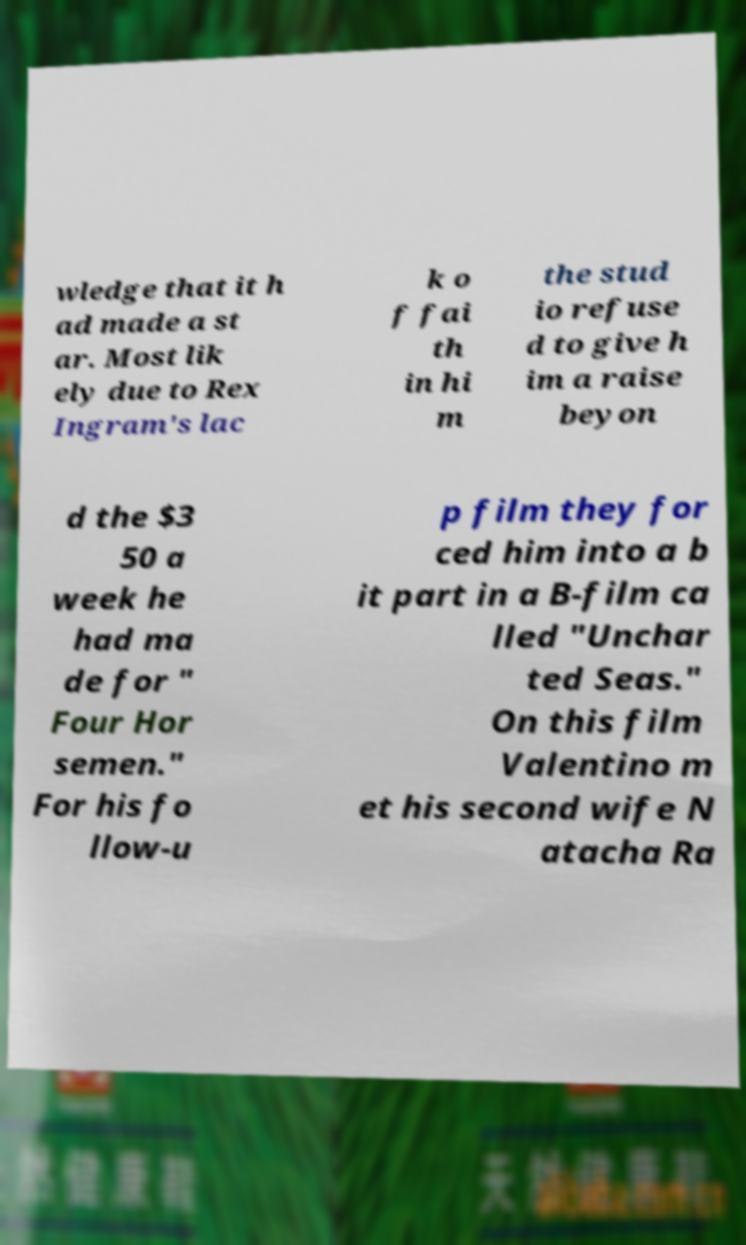Can you accurately transcribe the text from the provided image for me? wledge that it h ad made a st ar. Most lik ely due to Rex Ingram's lac k o f fai th in hi m the stud io refuse d to give h im a raise beyon d the $3 50 a week he had ma de for " Four Hor semen." For his fo llow-u p film they for ced him into a b it part in a B-film ca lled "Unchar ted Seas." On this film Valentino m et his second wife N atacha Ra 